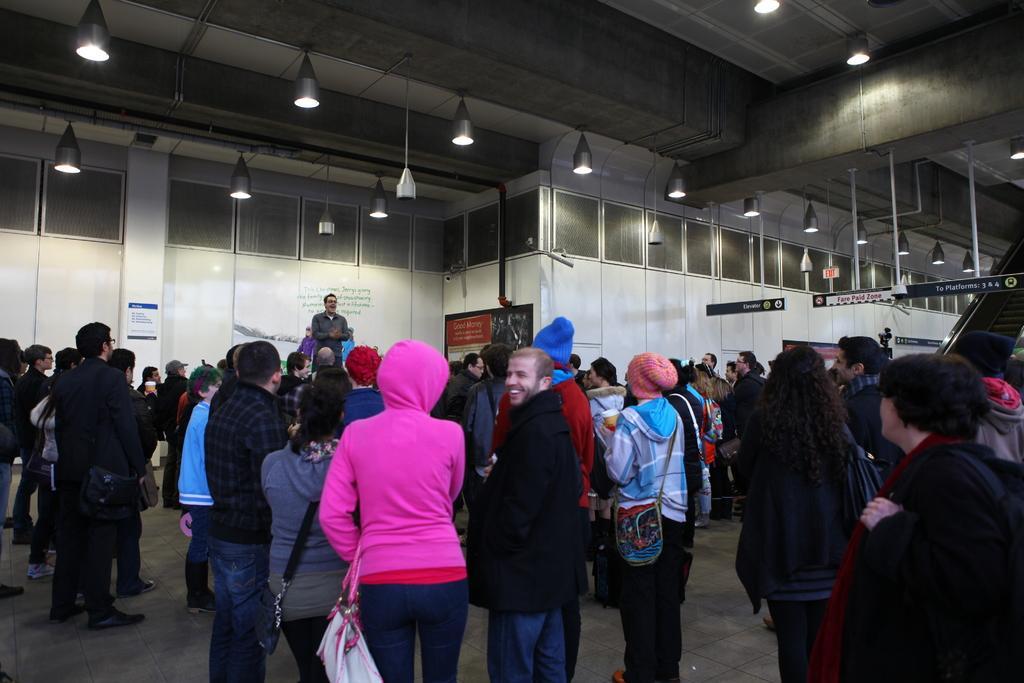Describe this image in one or two sentences. In this image there are a group of people standing, and some of them are wearing bags. And in the background there is one person standing and talking, and there are some boards, pillars, wall, windows, lights. And at the top there is ceiling and some lights and pillars, at the bottom there is floor and on the right side there are stairs and some boards. 